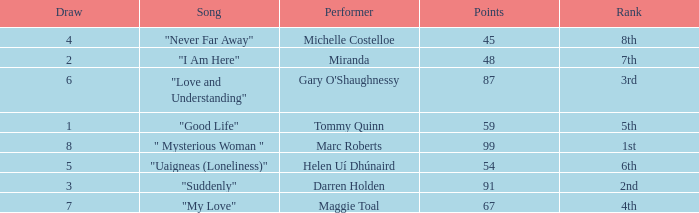What is the total number of draws for songs performed by Miranda with fewer than 48 points? 0.0. 